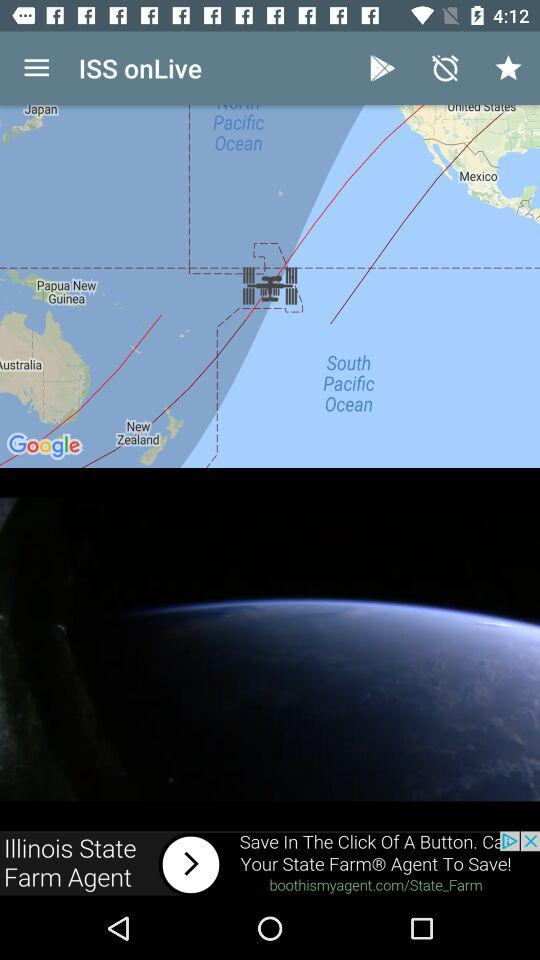What is the channel name? The channel name is "ISS onLive". 